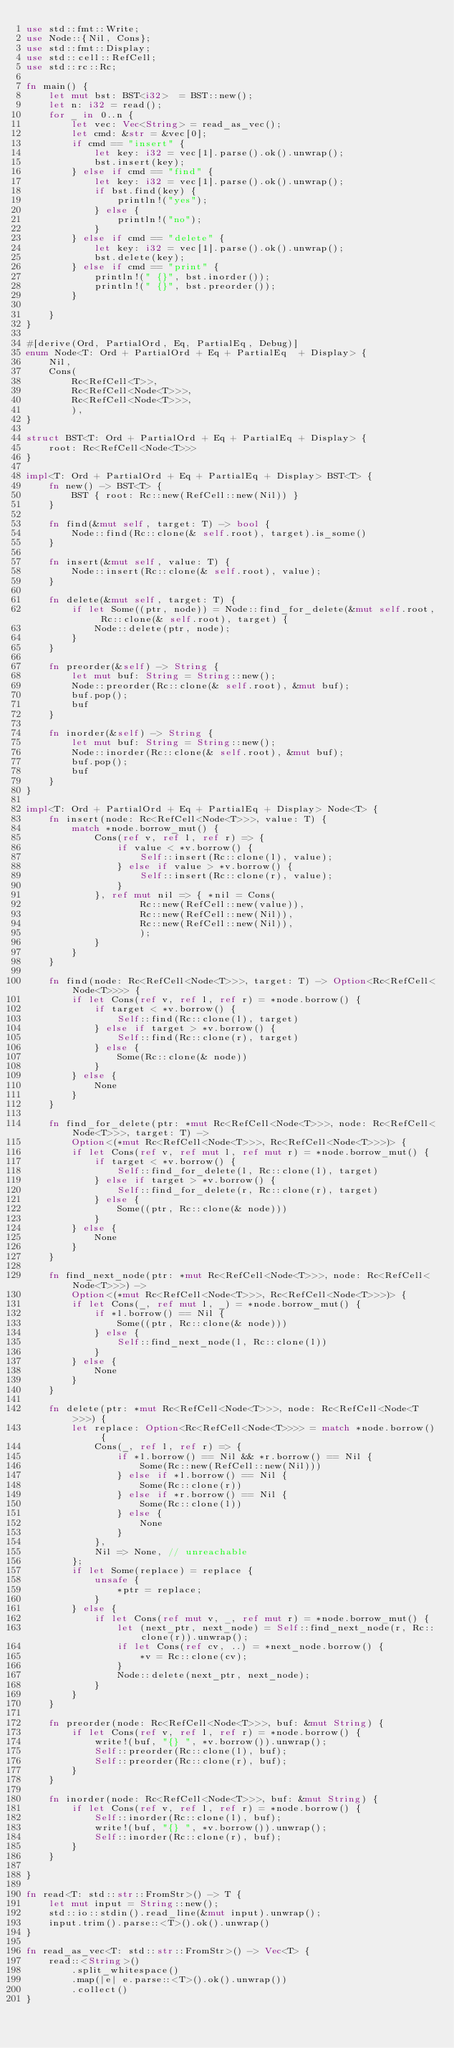<code> <loc_0><loc_0><loc_500><loc_500><_Rust_>use std::fmt::Write;
use Node::{Nil, Cons};
use std::fmt::Display;
use std::cell::RefCell;
use std::rc::Rc;

fn main() {
    let mut bst: BST<i32>  = BST::new();
    let n: i32 = read();
    for _ in 0..n {
        let vec: Vec<String> = read_as_vec();
        let cmd: &str = &vec[0];
        if cmd == "insert" {
            let key: i32 = vec[1].parse().ok().unwrap();
            bst.insert(key);
        } else if cmd == "find" {
            let key: i32 = vec[1].parse().ok().unwrap();
            if bst.find(key) {
                println!("yes");
            } else {
                println!("no");
            }
        } else if cmd == "delete" {
            let key: i32 = vec[1].parse().ok().unwrap();
            bst.delete(key);
        } else if cmd == "print" {
            println!(" {}", bst.inorder());
            println!(" {}", bst.preorder());
        }

    }
}

#[derive(Ord, PartialOrd, Eq, PartialEq, Debug)]
enum Node<T: Ord + PartialOrd + Eq + PartialEq  + Display> {
    Nil,
    Cons(
        Rc<RefCell<T>>,
        Rc<RefCell<Node<T>>>,
        Rc<RefCell<Node<T>>>,
        ),
}

struct BST<T: Ord + PartialOrd + Eq + PartialEq + Display> {
    root: Rc<RefCell<Node<T>>>
}

impl<T: Ord + PartialOrd + Eq + PartialEq + Display> BST<T> {
    fn new() -> BST<T> {
        BST { root: Rc::new(RefCell::new(Nil)) }
    }

    fn find(&mut self, target: T) -> bool {
        Node::find(Rc::clone(& self.root), target).is_some()
    }

    fn insert(&mut self, value: T) {
        Node::insert(Rc::clone(& self.root), value);
    }

    fn delete(&mut self, target: T) {
        if let Some((ptr, node)) = Node::find_for_delete(&mut self.root, Rc::clone(& self.root), target) {
            Node::delete(ptr, node);
        }
    }

    fn preorder(&self) -> String {
        let mut buf: String = String::new();
        Node::preorder(Rc::clone(& self.root), &mut buf);
        buf.pop();
        buf
    }

    fn inorder(&self) -> String {
        let mut buf: String = String::new();
        Node::inorder(Rc::clone(& self.root), &mut buf);
        buf.pop();
        buf
    }
}

impl<T: Ord + PartialOrd + Eq + PartialEq + Display> Node<T> {
    fn insert(node: Rc<RefCell<Node<T>>>, value: T) {
        match *node.borrow_mut() {
            Cons(ref v, ref l, ref r) => {
                if value < *v.borrow() {
                    Self::insert(Rc::clone(l), value);
                } else if value > *v.borrow() {
                    Self::insert(Rc::clone(r), value);
                }
            }, ref mut nil => { *nil = Cons(
                    Rc::new(RefCell::new(value)),
                    Rc::new(RefCell::new(Nil)),
                    Rc::new(RefCell::new(Nil)),
                    );
            }
        }
    }

    fn find(node: Rc<RefCell<Node<T>>>, target: T) -> Option<Rc<RefCell<Node<T>>>> {
        if let Cons(ref v, ref l, ref r) = *node.borrow() {
            if target < *v.borrow() {
                Self::find(Rc::clone(l), target)
            } else if target > *v.borrow() {
                Self::find(Rc::clone(r), target)
            } else {
                Some(Rc::clone(& node))
            }
        } else {
            None
        }
    }

    fn find_for_delete(ptr: *mut Rc<RefCell<Node<T>>>, node: Rc<RefCell<Node<T>>>, target: T) ->
        Option<(*mut Rc<RefCell<Node<T>>>, Rc<RefCell<Node<T>>>)> {
        if let Cons(ref v, ref mut l, ref mut r) = *node.borrow_mut() {
            if target < *v.borrow() {
                Self::find_for_delete(l, Rc::clone(l), target)
            } else if target > *v.borrow() {
                Self::find_for_delete(r, Rc::clone(r), target)
            } else {
                Some((ptr, Rc::clone(& node)))
            }
        } else {
            None
        }
    }

    fn find_next_node(ptr: *mut Rc<RefCell<Node<T>>>, node: Rc<RefCell<Node<T>>>) ->
        Option<(*mut Rc<RefCell<Node<T>>>, Rc<RefCell<Node<T>>>)> {
        if let Cons(_, ref mut l, _) = *node.borrow_mut() {
            if *l.borrow() == Nil {
                Some((ptr, Rc::clone(& node)))
            } else {
                Self::find_next_node(l, Rc::clone(l))
            }
        } else {
            None
        }
    }
    
    fn delete(ptr: *mut Rc<RefCell<Node<T>>>, node: Rc<RefCell<Node<T>>>) {
        let replace: Option<Rc<RefCell<Node<T>>>> = match *node.borrow() {
            Cons(_, ref l, ref r) => {
                if *l.borrow() == Nil && *r.borrow() == Nil {
                    Some(Rc::new(RefCell::new(Nil)))
                } else if *l.borrow() == Nil {
                    Some(Rc::clone(r))
                } else if *r.borrow() == Nil {
                    Some(Rc::clone(l))
                } else {
                    None
                }
            },
            Nil => None, // unreachable
        };
        if let Some(replace) = replace {
            unsafe {
                *ptr = replace;
            }
        } else {
            if let Cons(ref mut v, _, ref mut r) = *node.borrow_mut() {
                let (next_ptr, next_node) = Self::find_next_node(r, Rc::clone(r)).unwrap();
                if let Cons(ref cv, ..) = *next_node.borrow() {
                    *v = Rc::clone(cv);
                }
                Node::delete(next_ptr, next_node);
            }
        }
    }

    fn preorder(node: Rc<RefCell<Node<T>>>, buf: &mut String) {
        if let Cons(ref v, ref l, ref r) = *node.borrow() {
            write!(buf, "{} ", *v.borrow()).unwrap();
            Self::preorder(Rc::clone(l), buf);
            Self::preorder(Rc::clone(r), buf);
        }
    }

    fn inorder(node: Rc<RefCell<Node<T>>>, buf: &mut String) {
        if let Cons(ref v, ref l, ref r) = *node.borrow() {
            Self::inorder(Rc::clone(l), buf);
            write!(buf, "{} ", *v.borrow()).unwrap();
            Self::inorder(Rc::clone(r), buf);
        }
    }

}

fn read<T: std::str::FromStr>() -> T {
    let mut input = String::new();
    std::io::stdin().read_line(&mut input).unwrap();
    input.trim().parse::<T>().ok().unwrap()
}

fn read_as_vec<T: std::str::FromStr>() -> Vec<T> {
    read::<String>()
        .split_whitespace()
        .map(|e| e.parse::<T>().ok().unwrap())
        .collect()
}
</code> 